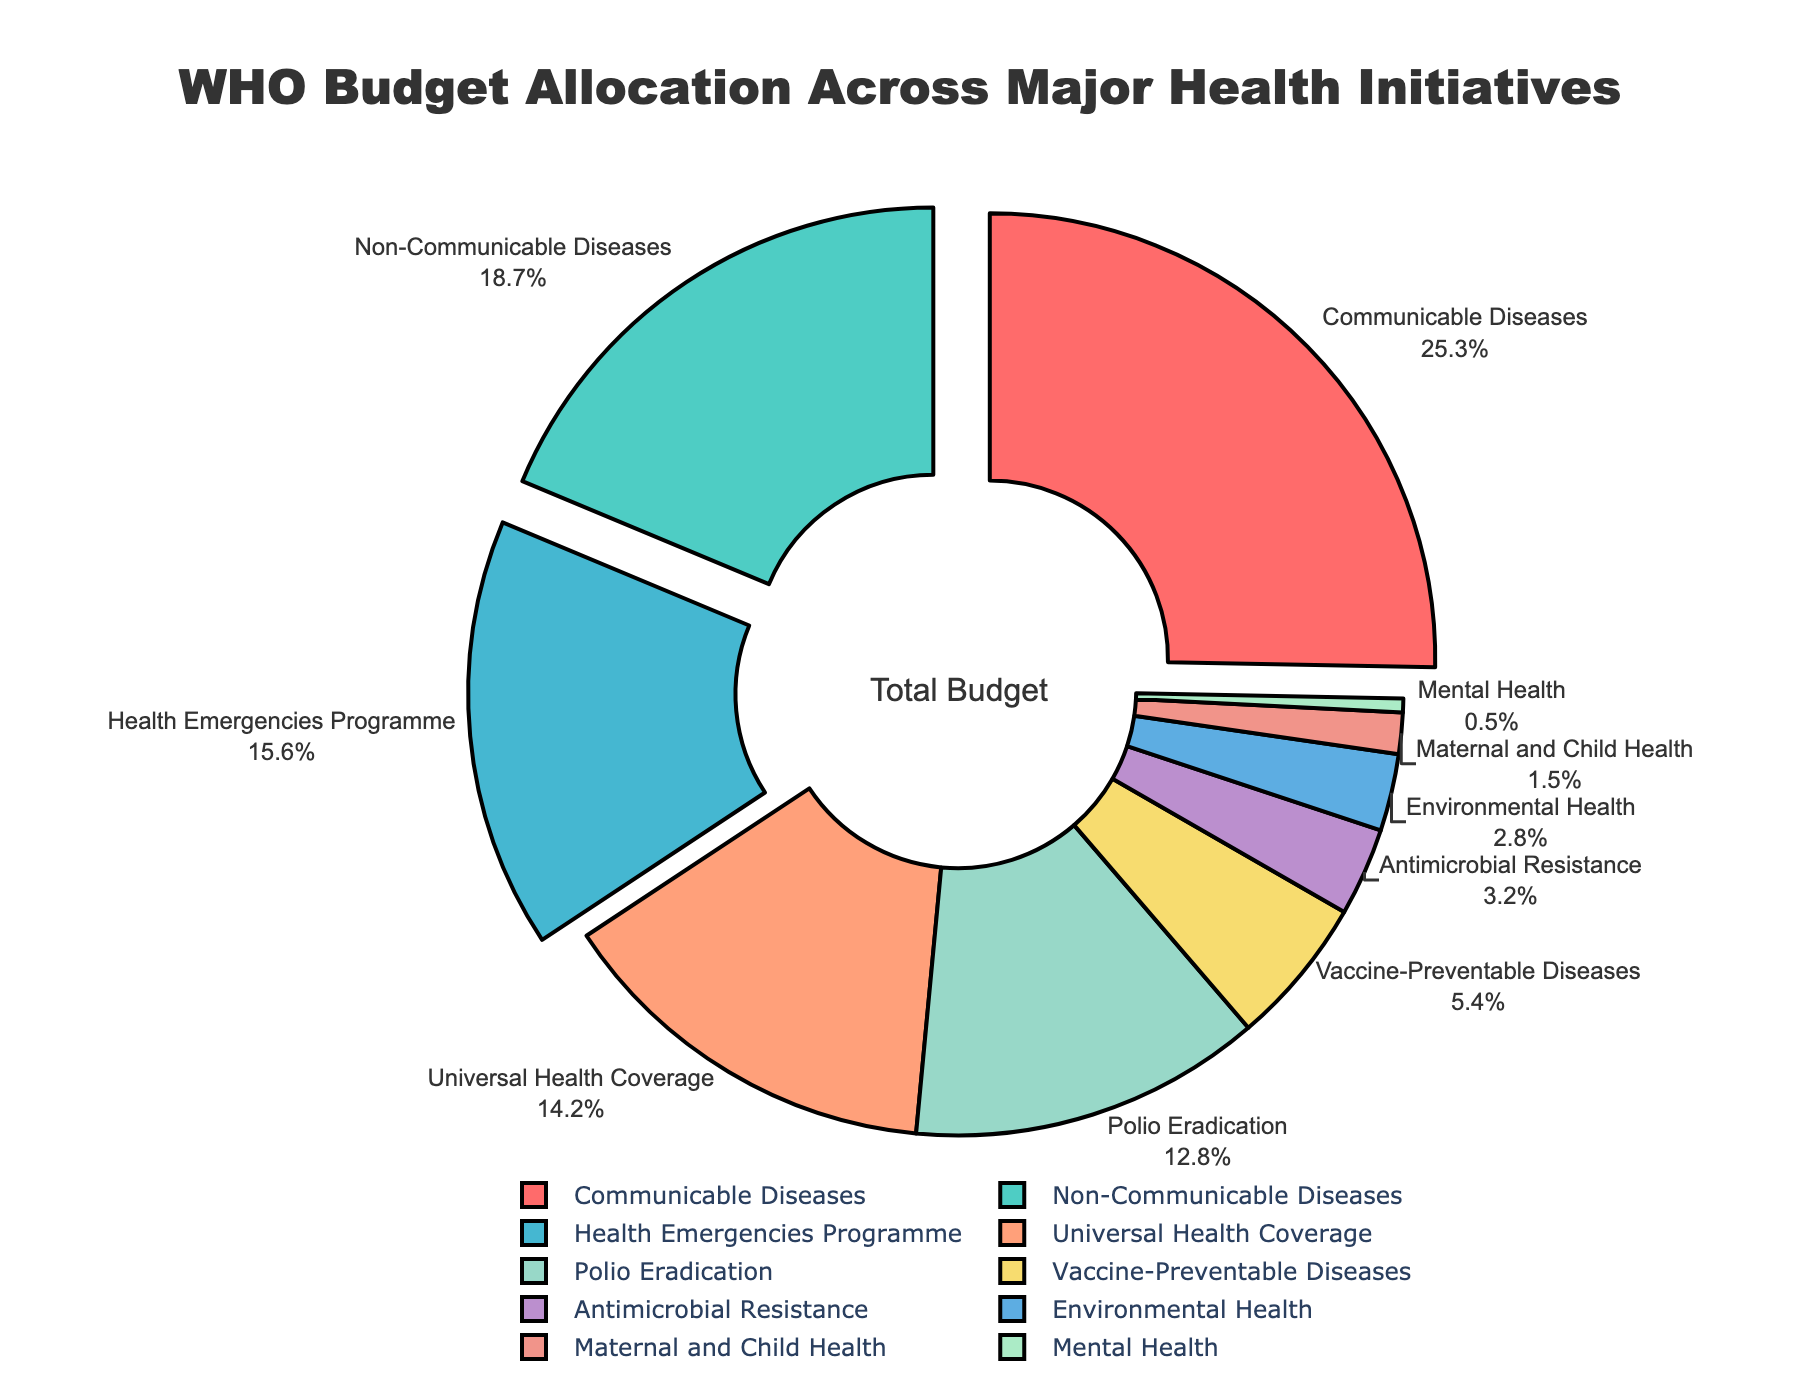What's the total percentage allocated to Communicable Diseases, Non-Communicable Diseases, and Health Emergencies Programme? First, identify the percentage for each initiative: Communicable Diseases (25.3%), Non-Communicable Diseases (18.7%), and Health Emergencies Programme (15.6%). Then sum these values: 25.3 + 18.7 + 15.6 = 59.6
Answer: 59.6% Is the budget allocation for Polio Eradication higher or lower than for Universal Health Coverage? Compare the percentage: Polio Eradication is 12.8% and Universal Health Coverage is 14.2%. Therefore, 12.8% < 14.2%
Answer: Lower Which initiative has the smallest budget allocation and how much is it? Identify the initiative with the smallest number: Mental Health has 0.5%
Answer: Mental Health, 0.5% What is the combined budget allocation for Vaccine-Preventable Diseases and Antimicrobial Resistance? Identify the percentage for each: Vaccine-Preventable Diseases (5.4%) and Antimicrobial Resistance (3.2%). Sum these values: 5.4 + 3.2 = 8.6
Answer: 8.6% Which initiatives are allocated a budget of more than 15% and what are their percentages? Identify initiatives with allocations greater than 15%: Communicable Diseases (25.3%) and Non-Communicable Diseases (18.7%) and Health Emergencies Programme (15.6%)
Answer: Communicable Diseases: 25.3%, Non-Communicable Diseases: 18.7%, Health Emergencies Programme: 15.6% How much greater is the budget allocation for Communicable Diseases than for Polio Eradication? Identify the percentage: Communicable Diseases (25.3%), Polio Eradication (12.8%). Calculate the difference: 25.3 - 12.8 = 12.5
Answer: 12.5% Which health initiative is represented by the yellow section of the pie chart? Observe the color associated with each section: Yellow is assigned to Antimicrobial Resistance
Answer: Antimicrobial Resistance What is the proportion of the budget allocated to Non-Communicable Diseases compared to Vaccine-Preventable Diseases? Identify the percentage: Non-Communicable Diseases (18.7%) and Vaccine-Preventable Diseases (5.4%). Calculate the ratio: 18.7 / 5.4 ≈ 3.46
Answer: Approximately 3.46 times If the total budget is $100 million, what is the budget allocation in dollars for Environmental Health? Identify the percentage for Environmental Health: 2.8%. Calculate the amount: $100 million * 2.8% = $2.8 million
Answer: $2.8 million 